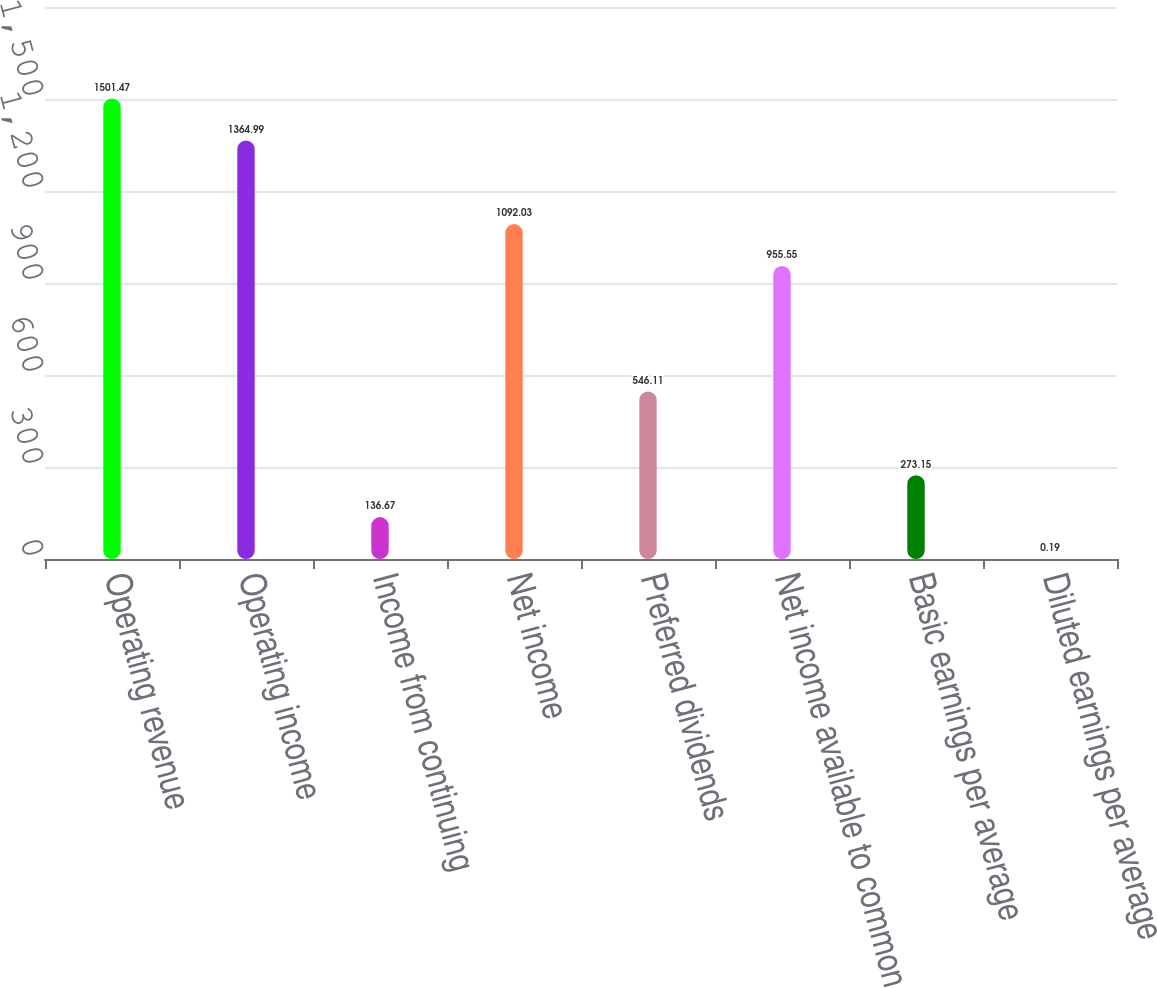Convert chart. <chart><loc_0><loc_0><loc_500><loc_500><bar_chart><fcel>Operating revenue<fcel>Operating income<fcel>Income from continuing<fcel>Net income<fcel>Preferred dividends<fcel>Net income available to common<fcel>Basic earnings per average<fcel>Diluted earnings per average<nl><fcel>1501.47<fcel>1364.99<fcel>136.67<fcel>1092.03<fcel>546.11<fcel>955.55<fcel>273.15<fcel>0.19<nl></chart> 